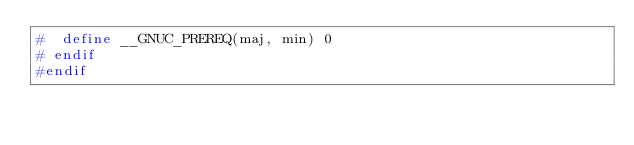<code> <loc_0><loc_0><loc_500><loc_500><_C_>#  define __GNUC_PREREQ(maj, min) 0
# endif
#endif
</code> 